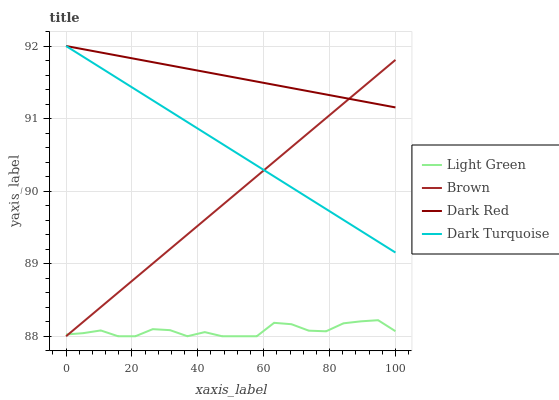Does Light Green have the minimum area under the curve?
Answer yes or no. Yes. Does Dark Red have the maximum area under the curve?
Answer yes or no. Yes. Does Dark Turquoise have the minimum area under the curve?
Answer yes or no. No. Does Dark Turquoise have the maximum area under the curve?
Answer yes or no. No. Is Brown the smoothest?
Answer yes or no. Yes. Is Light Green the roughest?
Answer yes or no. Yes. Is Dark Turquoise the smoothest?
Answer yes or no. No. Is Dark Turquoise the roughest?
Answer yes or no. No. Does Dark Turquoise have the lowest value?
Answer yes or no. No. Does Light Green have the highest value?
Answer yes or no. No. Is Light Green less than Dark Turquoise?
Answer yes or no. Yes. Is Dark Turquoise greater than Light Green?
Answer yes or no. Yes. Does Light Green intersect Dark Turquoise?
Answer yes or no. No. 